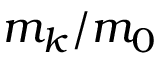<formula> <loc_0><loc_0><loc_500><loc_500>m _ { k } / m _ { 0 }</formula> 